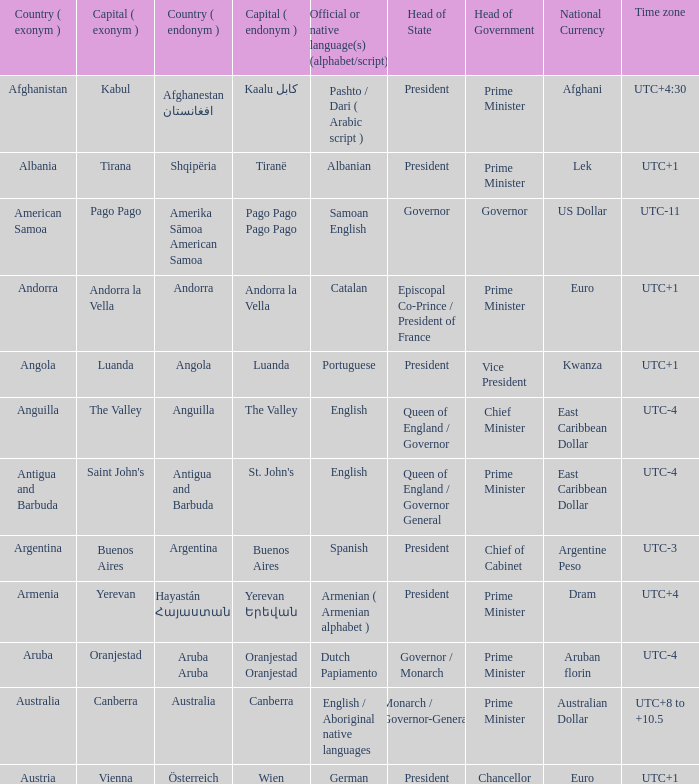What is the local name given to the capital of Anguilla? The Valley. 